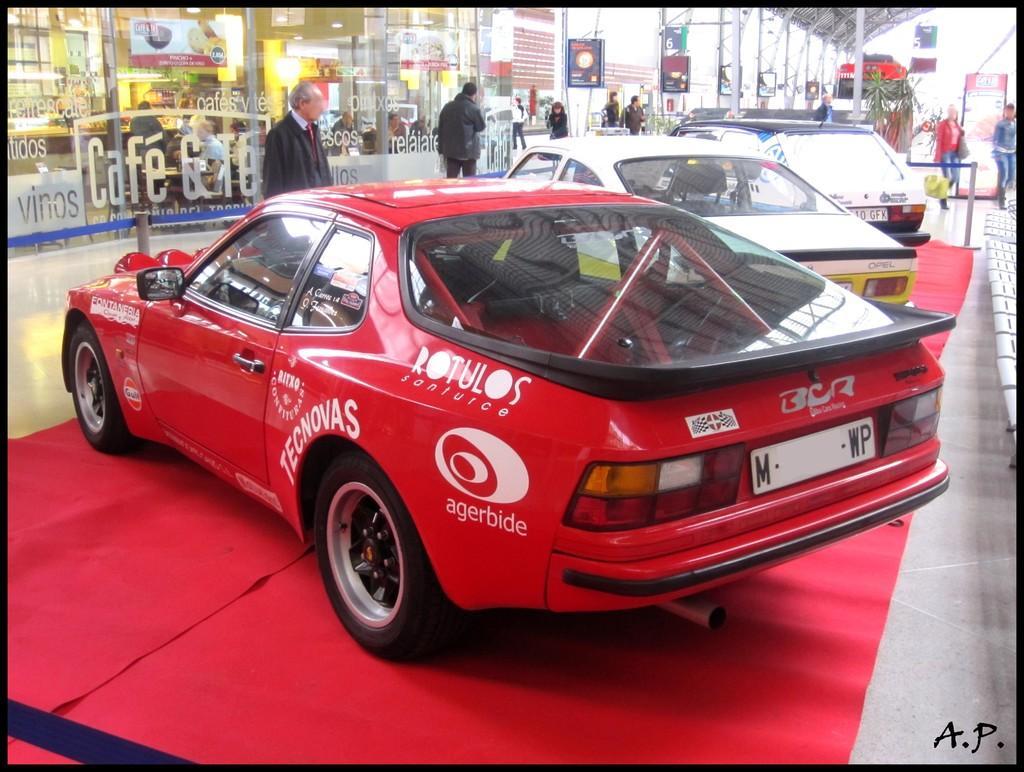Could you give a brief overview of what you see in this image? In the image in the center, we can see a few vehicles on the carpet. And we can see a few people are standing and holding some objects. In the background there is a building, poles, banners, sign boards and a few other objects. 